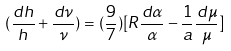<formula> <loc_0><loc_0><loc_500><loc_500>( \frac { d h } { h } + \frac { d \nu } { \nu } ) = ( \frac { 9 } { 7 } ) [ R \frac { d \alpha } { \alpha } - \frac { 1 } { a } \frac { d \mu } { \mu } ]</formula> 